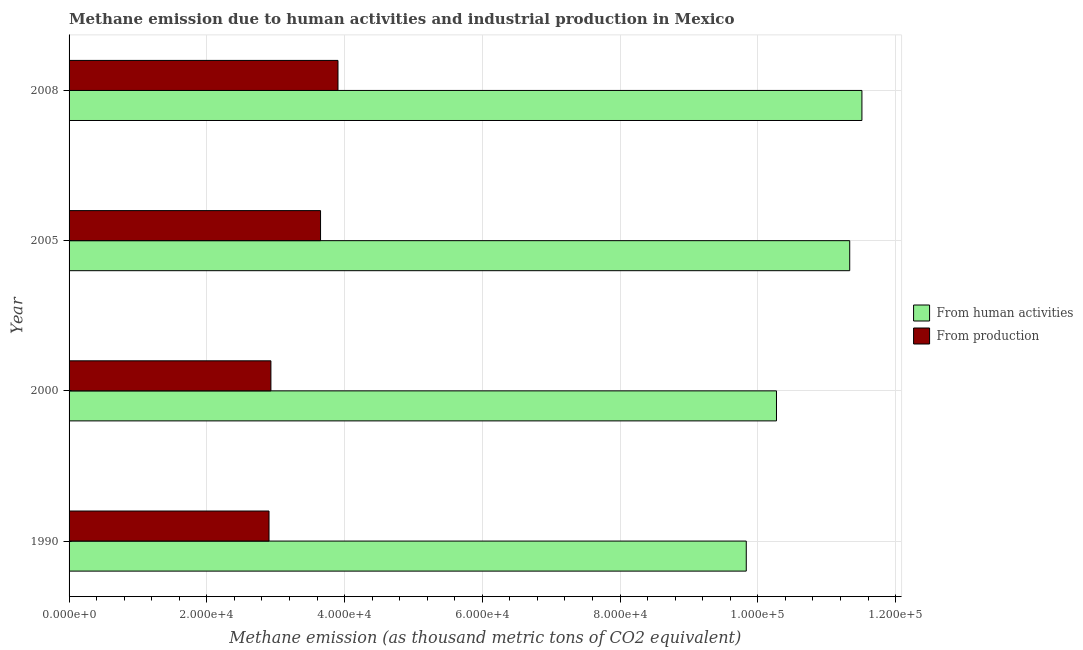How many different coloured bars are there?
Your response must be concise. 2. How many groups of bars are there?
Make the answer very short. 4. How many bars are there on the 4th tick from the bottom?
Ensure brevity in your answer.  2. What is the label of the 3rd group of bars from the top?
Offer a very short reply. 2000. What is the amount of emissions generated from industries in 2008?
Provide a short and direct response. 3.90e+04. Across all years, what is the maximum amount of emissions generated from industries?
Make the answer very short. 3.90e+04. Across all years, what is the minimum amount of emissions generated from industries?
Provide a succinct answer. 2.90e+04. In which year was the amount of emissions generated from industries maximum?
Make the answer very short. 2008. What is the total amount of emissions from human activities in the graph?
Give a very brief answer. 4.30e+05. What is the difference between the amount of emissions generated from industries in 1990 and that in 2008?
Keep it short and to the point. -1.00e+04. What is the difference between the amount of emissions from human activities in 2000 and the amount of emissions generated from industries in 2008?
Your answer should be very brief. 6.37e+04. What is the average amount of emissions generated from industries per year?
Offer a very short reply. 3.35e+04. In the year 2005, what is the difference between the amount of emissions generated from industries and amount of emissions from human activities?
Your answer should be compact. -7.68e+04. In how many years, is the amount of emissions generated from industries greater than 80000 thousand metric tons?
Your response must be concise. 0. What is the ratio of the amount of emissions from human activities in 2000 to that in 2008?
Keep it short and to the point. 0.89. What is the difference between the highest and the second highest amount of emissions generated from industries?
Your answer should be very brief. 2531.7. What is the difference between the highest and the lowest amount of emissions from human activities?
Give a very brief answer. 1.68e+04. In how many years, is the amount of emissions from human activities greater than the average amount of emissions from human activities taken over all years?
Provide a succinct answer. 2. What does the 1st bar from the top in 1990 represents?
Your response must be concise. From production. What does the 2nd bar from the bottom in 2005 represents?
Ensure brevity in your answer.  From production. What is the difference between two consecutive major ticks on the X-axis?
Make the answer very short. 2.00e+04. Are the values on the major ticks of X-axis written in scientific E-notation?
Your answer should be compact. Yes. How are the legend labels stacked?
Give a very brief answer. Vertical. What is the title of the graph?
Your answer should be very brief. Methane emission due to human activities and industrial production in Mexico. What is the label or title of the X-axis?
Offer a terse response. Methane emission (as thousand metric tons of CO2 equivalent). What is the label or title of the Y-axis?
Your response must be concise. Year. What is the Methane emission (as thousand metric tons of CO2 equivalent) of From human activities in 1990?
Your answer should be very brief. 9.83e+04. What is the Methane emission (as thousand metric tons of CO2 equivalent) in From production in 1990?
Your answer should be very brief. 2.90e+04. What is the Methane emission (as thousand metric tons of CO2 equivalent) in From human activities in 2000?
Your answer should be very brief. 1.03e+05. What is the Methane emission (as thousand metric tons of CO2 equivalent) in From production in 2000?
Provide a succinct answer. 2.93e+04. What is the Methane emission (as thousand metric tons of CO2 equivalent) of From human activities in 2005?
Give a very brief answer. 1.13e+05. What is the Methane emission (as thousand metric tons of CO2 equivalent) of From production in 2005?
Provide a succinct answer. 3.65e+04. What is the Methane emission (as thousand metric tons of CO2 equivalent) of From human activities in 2008?
Provide a succinct answer. 1.15e+05. What is the Methane emission (as thousand metric tons of CO2 equivalent) in From production in 2008?
Keep it short and to the point. 3.90e+04. Across all years, what is the maximum Methane emission (as thousand metric tons of CO2 equivalent) of From human activities?
Ensure brevity in your answer.  1.15e+05. Across all years, what is the maximum Methane emission (as thousand metric tons of CO2 equivalent) of From production?
Give a very brief answer. 3.90e+04. Across all years, what is the minimum Methane emission (as thousand metric tons of CO2 equivalent) of From human activities?
Provide a succinct answer. 9.83e+04. Across all years, what is the minimum Methane emission (as thousand metric tons of CO2 equivalent) of From production?
Provide a short and direct response. 2.90e+04. What is the total Methane emission (as thousand metric tons of CO2 equivalent) of From human activities in the graph?
Your answer should be very brief. 4.30e+05. What is the total Methane emission (as thousand metric tons of CO2 equivalent) in From production in the graph?
Provide a short and direct response. 1.34e+05. What is the difference between the Methane emission (as thousand metric tons of CO2 equivalent) of From human activities in 1990 and that in 2000?
Keep it short and to the point. -4388.4. What is the difference between the Methane emission (as thousand metric tons of CO2 equivalent) of From production in 1990 and that in 2000?
Ensure brevity in your answer.  -274.1. What is the difference between the Methane emission (as thousand metric tons of CO2 equivalent) in From human activities in 1990 and that in 2005?
Provide a short and direct response. -1.50e+04. What is the difference between the Methane emission (as thousand metric tons of CO2 equivalent) in From production in 1990 and that in 2005?
Offer a very short reply. -7482. What is the difference between the Methane emission (as thousand metric tons of CO2 equivalent) in From human activities in 1990 and that in 2008?
Provide a succinct answer. -1.68e+04. What is the difference between the Methane emission (as thousand metric tons of CO2 equivalent) of From production in 1990 and that in 2008?
Make the answer very short. -1.00e+04. What is the difference between the Methane emission (as thousand metric tons of CO2 equivalent) in From human activities in 2000 and that in 2005?
Offer a very short reply. -1.06e+04. What is the difference between the Methane emission (as thousand metric tons of CO2 equivalent) of From production in 2000 and that in 2005?
Your answer should be very brief. -7207.9. What is the difference between the Methane emission (as thousand metric tons of CO2 equivalent) in From human activities in 2000 and that in 2008?
Provide a short and direct response. -1.24e+04. What is the difference between the Methane emission (as thousand metric tons of CO2 equivalent) in From production in 2000 and that in 2008?
Keep it short and to the point. -9739.6. What is the difference between the Methane emission (as thousand metric tons of CO2 equivalent) of From human activities in 2005 and that in 2008?
Provide a short and direct response. -1773.1. What is the difference between the Methane emission (as thousand metric tons of CO2 equivalent) of From production in 2005 and that in 2008?
Offer a terse response. -2531.7. What is the difference between the Methane emission (as thousand metric tons of CO2 equivalent) of From human activities in 1990 and the Methane emission (as thousand metric tons of CO2 equivalent) of From production in 2000?
Give a very brief answer. 6.90e+04. What is the difference between the Methane emission (as thousand metric tons of CO2 equivalent) in From human activities in 1990 and the Methane emission (as thousand metric tons of CO2 equivalent) in From production in 2005?
Provide a succinct answer. 6.18e+04. What is the difference between the Methane emission (as thousand metric tons of CO2 equivalent) in From human activities in 1990 and the Methane emission (as thousand metric tons of CO2 equivalent) in From production in 2008?
Give a very brief answer. 5.93e+04. What is the difference between the Methane emission (as thousand metric tons of CO2 equivalent) in From human activities in 2000 and the Methane emission (as thousand metric tons of CO2 equivalent) in From production in 2005?
Your response must be concise. 6.62e+04. What is the difference between the Methane emission (as thousand metric tons of CO2 equivalent) of From human activities in 2000 and the Methane emission (as thousand metric tons of CO2 equivalent) of From production in 2008?
Make the answer very short. 6.37e+04. What is the difference between the Methane emission (as thousand metric tons of CO2 equivalent) of From human activities in 2005 and the Methane emission (as thousand metric tons of CO2 equivalent) of From production in 2008?
Ensure brevity in your answer.  7.43e+04. What is the average Methane emission (as thousand metric tons of CO2 equivalent) in From human activities per year?
Offer a very short reply. 1.07e+05. What is the average Methane emission (as thousand metric tons of CO2 equivalent) of From production per year?
Offer a terse response. 3.35e+04. In the year 1990, what is the difference between the Methane emission (as thousand metric tons of CO2 equivalent) in From human activities and Methane emission (as thousand metric tons of CO2 equivalent) in From production?
Offer a very short reply. 6.93e+04. In the year 2000, what is the difference between the Methane emission (as thousand metric tons of CO2 equivalent) of From human activities and Methane emission (as thousand metric tons of CO2 equivalent) of From production?
Make the answer very short. 7.34e+04. In the year 2005, what is the difference between the Methane emission (as thousand metric tons of CO2 equivalent) of From human activities and Methane emission (as thousand metric tons of CO2 equivalent) of From production?
Provide a succinct answer. 7.68e+04. In the year 2008, what is the difference between the Methane emission (as thousand metric tons of CO2 equivalent) of From human activities and Methane emission (as thousand metric tons of CO2 equivalent) of From production?
Your answer should be compact. 7.61e+04. What is the ratio of the Methane emission (as thousand metric tons of CO2 equivalent) in From human activities in 1990 to that in 2000?
Make the answer very short. 0.96. What is the ratio of the Methane emission (as thousand metric tons of CO2 equivalent) of From production in 1990 to that in 2000?
Offer a very short reply. 0.99. What is the ratio of the Methane emission (as thousand metric tons of CO2 equivalent) of From human activities in 1990 to that in 2005?
Your answer should be very brief. 0.87. What is the ratio of the Methane emission (as thousand metric tons of CO2 equivalent) of From production in 1990 to that in 2005?
Keep it short and to the point. 0.8. What is the ratio of the Methane emission (as thousand metric tons of CO2 equivalent) of From human activities in 1990 to that in 2008?
Keep it short and to the point. 0.85. What is the ratio of the Methane emission (as thousand metric tons of CO2 equivalent) of From production in 1990 to that in 2008?
Your answer should be very brief. 0.74. What is the ratio of the Methane emission (as thousand metric tons of CO2 equivalent) of From human activities in 2000 to that in 2005?
Your answer should be compact. 0.91. What is the ratio of the Methane emission (as thousand metric tons of CO2 equivalent) of From production in 2000 to that in 2005?
Offer a terse response. 0.8. What is the ratio of the Methane emission (as thousand metric tons of CO2 equivalent) of From human activities in 2000 to that in 2008?
Offer a very short reply. 0.89. What is the ratio of the Methane emission (as thousand metric tons of CO2 equivalent) of From production in 2000 to that in 2008?
Provide a short and direct response. 0.75. What is the ratio of the Methane emission (as thousand metric tons of CO2 equivalent) of From human activities in 2005 to that in 2008?
Offer a terse response. 0.98. What is the ratio of the Methane emission (as thousand metric tons of CO2 equivalent) in From production in 2005 to that in 2008?
Ensure brevity in your answer.  0.94. What is the difference between the highest and the second highest Methane emission (as thousand metric tons of CO2 equivalent) in From human activities?
Provide a succinct answer. 1773.1. What is the difference between the highest and the second highest Methane emission (as thousand metric tons of CO2 equivalent) of From production?
Give a very brief answer. 2531.7. What is the difference between the highest and the lowest Methane emission (as thousand metric tons of CO2 equivalent) of From human activities?
Keep it short and to the point. 1.68e+04. What is the difference between the highest and the lowest Methane emission (as thousand metric tons of CO2 equivalent) of From production?
Ensure brevity in your answer.  1.00e+04. 